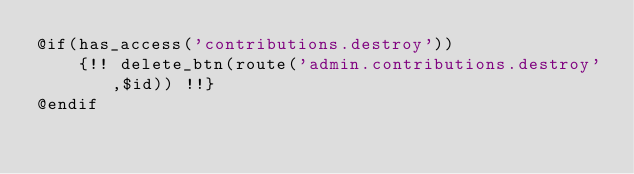<code> <loc_0><loc_0><loc_500><loc_500><_PHP_>@if(has_access('contributions.destroy'))
    {!! delete_btn(route('admin.contributions.destroy',$id)) !!}
@endif</code> 